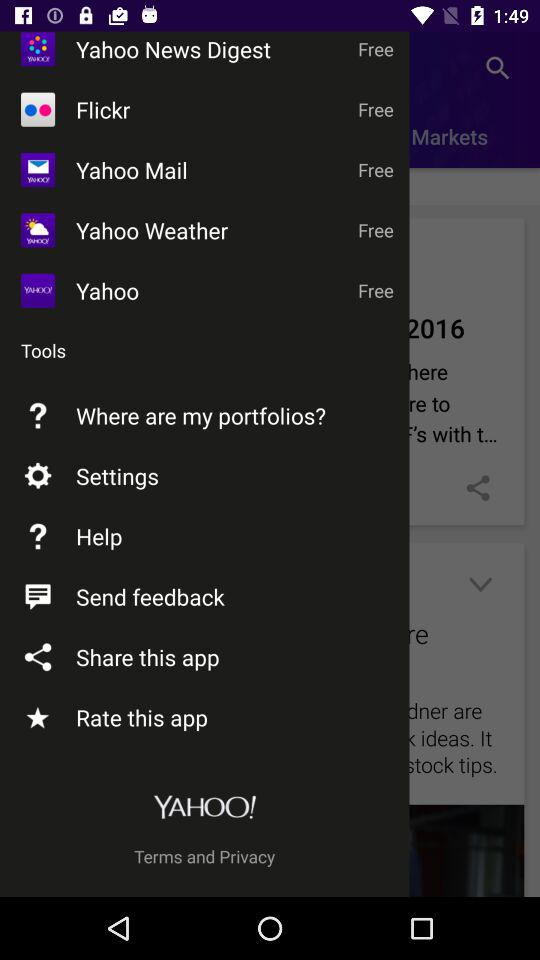Is "Flickr" free or paid?
Answer the question using a single word or phrase. "Flickr" is free. 